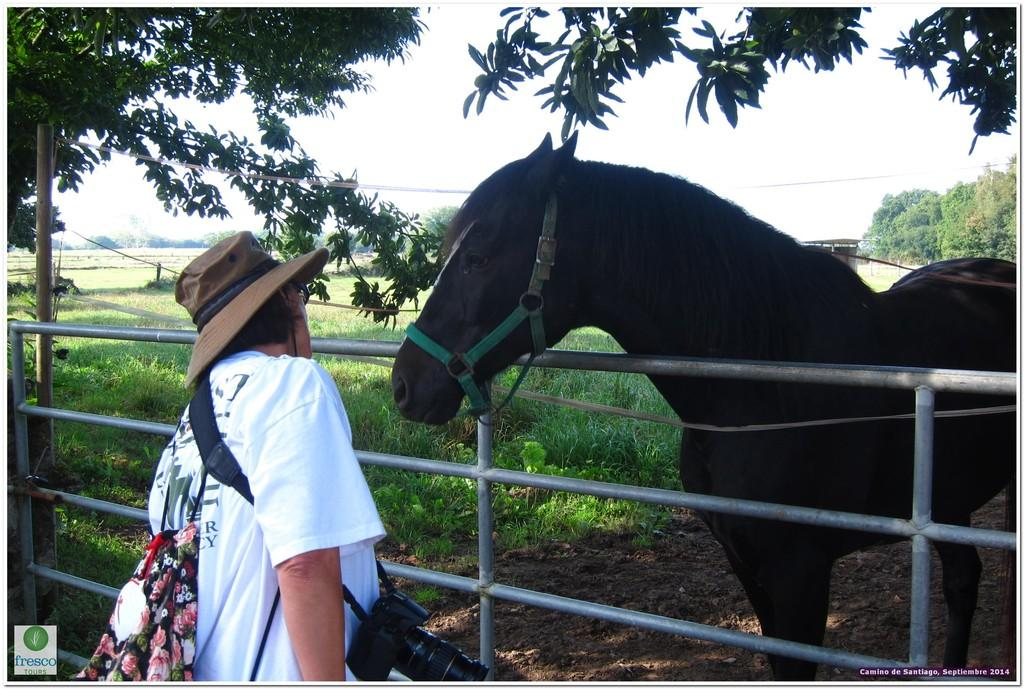What animal can be seen in the image? There is a horse in the image. Who or what is on the left side of the image? There is a person on the left side of the image. What object is used to capture images in the image? There is a camera visible in the image. What separates the horse from the person in the image? There is a fence in the image. What type of vegetation is visible in the background of the image? There are trees in the background of the image. What can be seen in the sky in the image? The sky is visible in the background of the image. What type of ground surface is present in the image? There is grass in the image. What type of pie is being served to the horse in the image? There is no pie present in the image, and the horse is not being served any food. What kind of apparatus is being used by the person to interact with the horse in the image? There is no apparatus visible in the image; the person is simply standing next to the horse. 